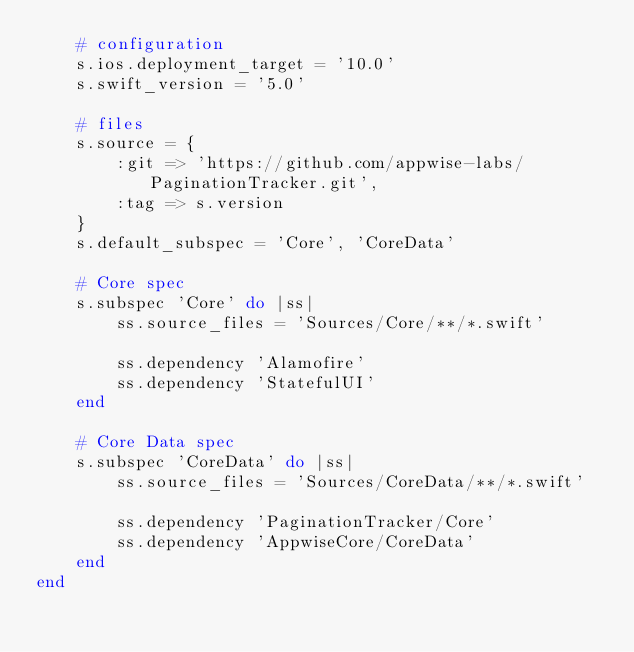<code> <loc_0><loc_0><loc_500><loc_500><_Ruby_>	# configuration
	s.ios.deployment_target = '10.0'
	s.swift_version = '5.0'

	# files
	s.source = {
		:git => 'https://github.com/appwise-labs/PaginationTracker.git',
		:tag => s.version
	}
	s.default_subspec = 'Core', 'CoreData'

	# Core spec
	s.subspec 'Core' do |ss|
		ss.source_files = 'Sources/Core/**/*.swift'

		ss.dependency 'Alamofire'
		ss.dependency 'StatefulUI'
	end

	# Core Data spec
	s.subspec 'CoreData' do |ss|
		ss.source_files = 'Sources/CoreData/**/*.swift'

		ss.dependency 'PaginationTracker/Core'
		ss.dependency 'AppwiseCore/CoreData'
	end
end
</code> 